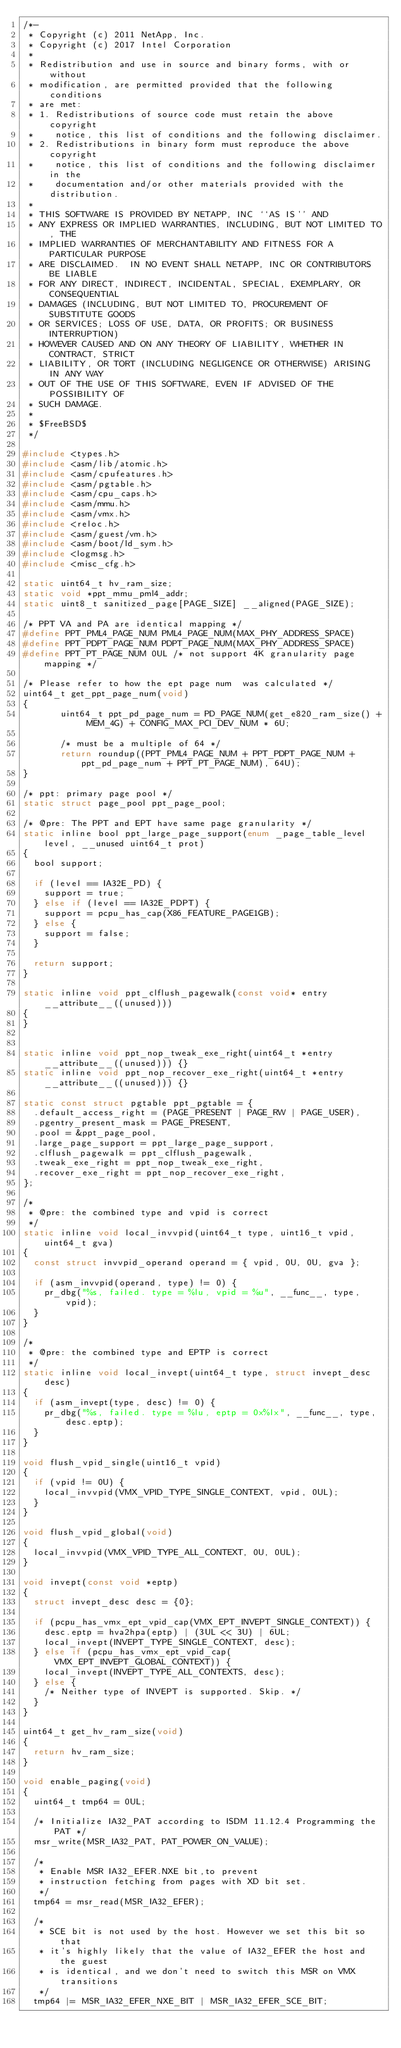Convert code to text. <code><loc_0><loc_0><loc_500><loc_500><_C_>/*-
 * Copyright (c) 2011 NetApp, Inc.
 * Copyright (c) 2017 Intel Corporation
 *
 * Redistribution and use in source and binary forms, with or without
 * modification, are permitted provided that the following conditions
 * are met:
 * 1. Redistributions of source code must retain the above copyright
 *    notice, this list of conditions and the following disclaimer.
 * 2. Redistributions in binary form must reproduce the above copyright
 *    notice, this list of conditions and the following disclaimer in the
 *    documentation and/or other materials provided with the distribution.
 *
 * THIS SOFTWARE IS PROVIDED BY NETAPP, INC ``AS IS'' AND
 * ANY EXPRESS OR IMPLIED WARRANTIES, INCLUDING, BUT NOT LIMITED TO, THE
 * IMPLIED WARRANTIES OF MERCHANTABILITY AND FITNESS FOR A PARTICULAR PURPOSE
 * ARE DISCLAIMED.  IN NO EVENT SHALL NETAPP, INC OR CONTRIBUTORS BE LIABLE
 * FOR ANY DIRECT, INDIRECT, INCIDENTAL, SPECIAL, EXEMPLARY, OR CONSEQUENTIAL
 * DAMAGES (INCLUDING, BUT NOT LIMITED TO, PROCUREMENT OF SUBSTITUTE GOODS
 * OR SERVICES; LOSS OF USE, DATA, OR PROFITS; OR BUSINESS INTERRUPTION)
 * HOWEVER CAUSED AND ON ANY THEORY OF LIABILITY, WHETHER IN CONTRACT, STRICT
 * LIABILITY, OR TORT (INCLUDING NEGLIGENCE OR OTHERWISE) ARISING IN ANY WAY
 * OUT OF THE USE OF THIS SOFTWARE, EVEN IF ADVISED OF THE POSSIBILITY OF
 * SUCH DAMAGE.
 *
 * $FreeBSD$
 */

#include <types.h>
#include <asm/lib/atomic.h>
#include <asm/cpufeatures.h>
#include <asm/pgtable.h>
#include <asm/cpu_caps.h>
#include <asm/mmu.h>
#include <asm/vmx.h>
#include <reloc.h>
#include <asm/guest/vm.h>
#include <asm/boot/ld_sym.h>
#include <logmsg.h>
#include <misc_cfg.h>

static uint64_t hv_ram_size;
static void *ppt_mmu_pml4_addr;
static uint8_t sanitized_page[PAGE_SIZE] __aligned(PAGE_SIZE);

/* PPT VA and PA are identical mapping */
#define PPT_PML4_PAGE_NUM	PML4_PAGE_NUM(MAX_PHY_ADDRESS_SPACE)
#define PPT_PDPT_PAGE_NUM	PDPT_PAGE_NUM(MAX_PHY_ADDRESS_SPACE)
#define PPT_PT_PAGE_NUM	0UL	/* not support 4K granularity page mapping */

/* Please refer to how the ept page num  was calculated */
uint64_t get_ppt_page_num(void)
{
       uint64_t ppt_pd_page_num = PD_PAGE_NUM(get_e820_ram_size() + MEM_4G) + CONFIG_MAX_PCI_DEV_NUM * 6U;

       /* must be a multiple of 64 */
       return roundup((PPT_PML4_PAGE_NUM + PPT_PDPT_PAGE_NUM + ppt_pd_page_num + PPT_PT_PAGE_NUM), 64U);
}

/* ppt: primary page pool */
static struct page_pool ppt_page_pool;

/* @pre: The PPT and EPT have same page granularity */
static inline bool ppt_large_page_support(enum _page_table_level level, __unused uint64_t prot)
{
	bool support;

	if (level == IA32E_PD) {
		support = true;
	} else if (level == IA32E_PDPT) {
		support = pcpu_has_cap(X86_FEATURE_PAGE1GB);
	} else {
		support = false;
	}

	return support;
}

static inline void ppt_clflush_pagewalk(const void* entry __attribute__((unused)))
{
}


static inline void ppt_nop_tweak_exe_right(uint64_t *entry __attribute__((unused))) {}
static inline void ppt_nop_recover_exe_right(uint64_t *entry __attribute__((unused))) {}

static const struct pgtable ppt_pgtable = {
	.default_access_right = (PAGE_PRESENT | PAGE_RW | PAGE_USER),
	.pgentry_present_mask = PAGE_PRESENT,
	.pool = &ppt_page_pool,
	.large_page_support = ppt_large_page_support,
	.clflush_pagewalk = ppt_clflush_pagewalk,
	.tweak_exe_right = ppt_nop_tweak_exe_right,
	.recover_exe_right = ppt_nop_recover_exe_right,
};

/*
 * @pre: the combined type and vpid is correct
 */
static inline void local_invvpid(uint64_t type, uint16_t vpid, uint64_t gva)
{
	const struct invvpid_operand operand = { vpid, 0U, 0U, gva };

	if (asm_invvpid(operand, type) != 0) {
		pr_dbg("%s, failed. type = %lu, vpid = %u", __func__, type, vpid);
	}
}

/*
 * @pre: the combined type and EPTP is correct
 */
static inline void local_invept(uint64_t type, struct invept_desc desc)
{
	if (asm_invept(type, desc) != 0) {
		pr_dbg("%s, failed. type = %lu, eptp = 0x%lx", __func__, type, desc.eptp);
	}
}

void flush_vpid_single(uint16_t vpid)
{
	if (vpid != 0U) {
		local_invvpid(VMX_VPID_TYPE_SINGLE_CONTEXT, vpid, 0UL);
	}
}

void flush_vpid_global(void)
{
	local_invvpid(VMX_VPID_TYPE_ALL_CONTEXT, 0U, 0UL);
}

void invept(const void *eptp)
{
	struct invept_desc desc = {0};

	if (pcpu_has_vmx_ept_vpid_cap(VMX_EPT_INVEPT_SINGLE_CONTEXT)) {
		desc.eptp = hva2hpa(eptp) | (3UL << 3U) | 6UL;
		local_invept(INVEPT_TYPE_SINGLE_CONTEXT, desc);
	} else if (pcpu_has_vmx_ept_vpid_cap(VMX_EPT_INVEPT_GLOBAL_CONTEXT)) {
		local_invept(INVEPT_TYPE_ALL_CONTEXTS, desc);
	} else {
		/* Neither type of INVEPT is supported. Skip. */
	}
}

uint64_t get_hv_ram_size(void)
{
	return hv_ram_size;
}

void enable_paging(void)
{
	uint64_t tmp64 = 0UL;

	/* Initialize IA32_PAT according to ISDM 11.12.4 Programming the PAT */
	msr_write(MSR_IA32_PAT, PAT_POWER_ON_VALUE);

	/*
	 * Enable MSR IA32_EFER.NXE bit,to prevent
	 * instruction fetching from pages with XD bit set.
	 */
	tmp64 = msr_read(MSR_IA32_EFER);

	/*
	 * SCE bit is not used by the host. However we set this bit so that
	 * it's highly likely that the value of IA32_EFER the host and the guest
	 * is identical, and we don't need to switch this MSR on VMX transitions
	 */
	tmp64 |= MSR_IA32_EFER_NXE_BIT | MSR_IA32_EFER_SCE_BIT;</code> 